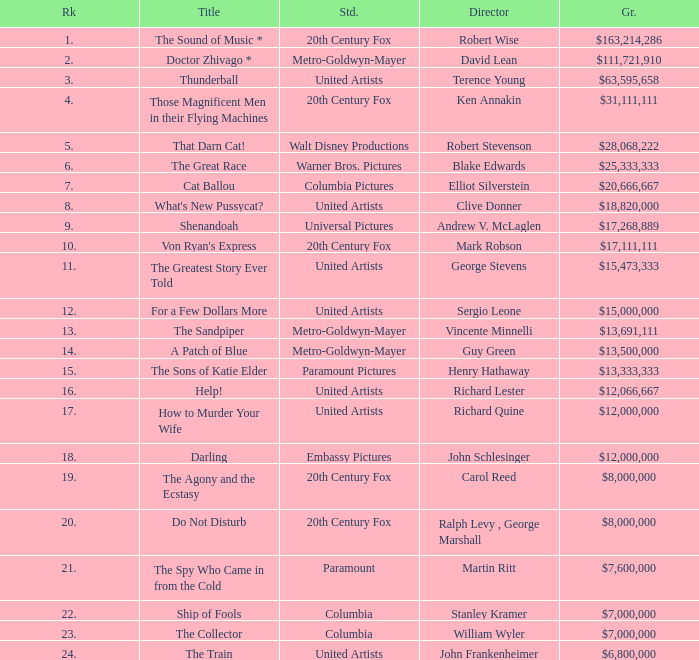When the title is "do not disturb," what is the studio? 20th Century Fox. 